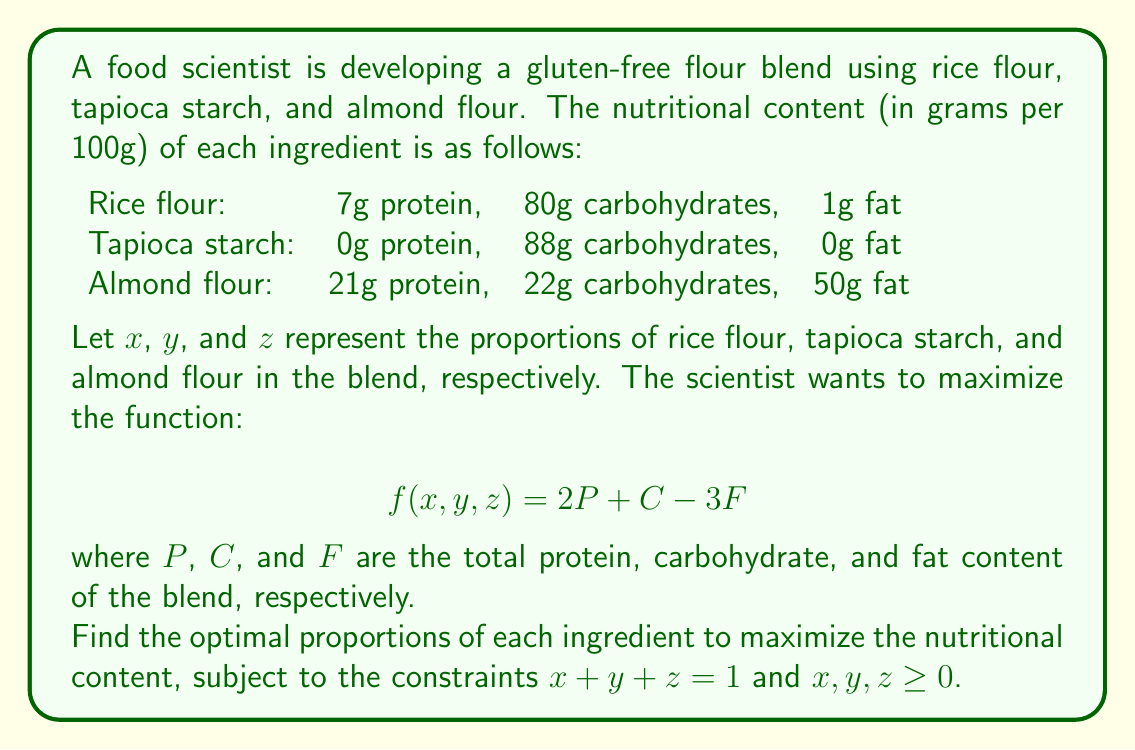Provide a solution to this math problem. To solve this optimization problem, we'll use the method of Lagrange multipliers.

Step 1: Express $P$, $C$, and $F$ in terms of $x$, $y$, and $z$:
$P = 7x + 0y + 21z$
$C = 80x + 88y + 22z$
$F = 1x + 0y + 50z$

Step 2: Substitute these into the objective function:
$$f(x,y,z) = 2(7x + 21z) + (80x + 88y + 22z) - 3(1x + 50z)$$
$$f(x,y,z) = 94x + 88y - 107z$$

Step 3: Set up the Lagrangian function with the constraint $x + y + z = 1$:
$$L(x,y,z,\lambda) = 94x + 88y - 107z - \lambda(x + y + z - 1)$$

Step 4: Calculate partial derivatives and set them to zero:
$$\frac{\partial L}{\partial x} = 94 - \lambda = 0$$
$$\frac{\partial L}{\partial y} = 88 - \lambda = 0$$
$$\frac{\partial L}{\partial z} = -107 - \lambda = 0$$
$$\frac{\partial L}{\partial \lambda} = x + y + z - 1 = 0$$

Step 5: From these equations, we can see that:
$\lambda = 94$
$\lambda = 88$
$\lambda = -107$

These cannot all be true simultaneously, which means the maximum occurs at the boundary of our feasible region.

Step 6: Check the vertices of the feasible region:
(1,0,0): $f(1,0,0) = 94$
(0,1,0): $f(0,1,0) = 88$
(0,0,1): $f(0,0,1) = -107$

Step 7: The maximum value occurs at (1,0,0), which corresponds to using 100% rice flour.
Answer: (1, 0, 0) 